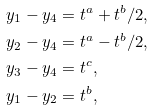Convert formula to latex. <formula><loc_0><loc_0><loc_500><loc_500>& y _ { 1 } - y _ { 4 } = t ^ { a } + t ^ { b } / 2 , \\ & y _ { 2 } - y _ { 4 } = t ^ { a } - t ^ { b } / 2 , \\ & y _ { 3 } - y _ { 4 } = t ^ { c } , \\ & y _ { 1 } - y _ { 2 } = t ^ { b } ,</formula> 